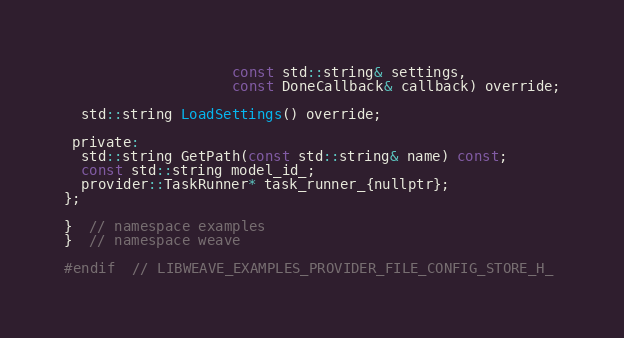<code> <loc_0><loc_0><loc_500><loc_500><_C_>                    const std::string& settings,
                    const DoneCallback& callback) override;

  std::string LoadSettings() override;

 private:
  std::string GetPath(const std::string& name) const;
  const std::string model_id_;
  provider::TaskRunner* task_runner_{nullptr};
};

}  // namespace examples
}  // namespace weave

#endif  // LIBWEAVE_EXAMPLES_PROVIDER_FILE_CONFIG_STORE_H_
</code> 